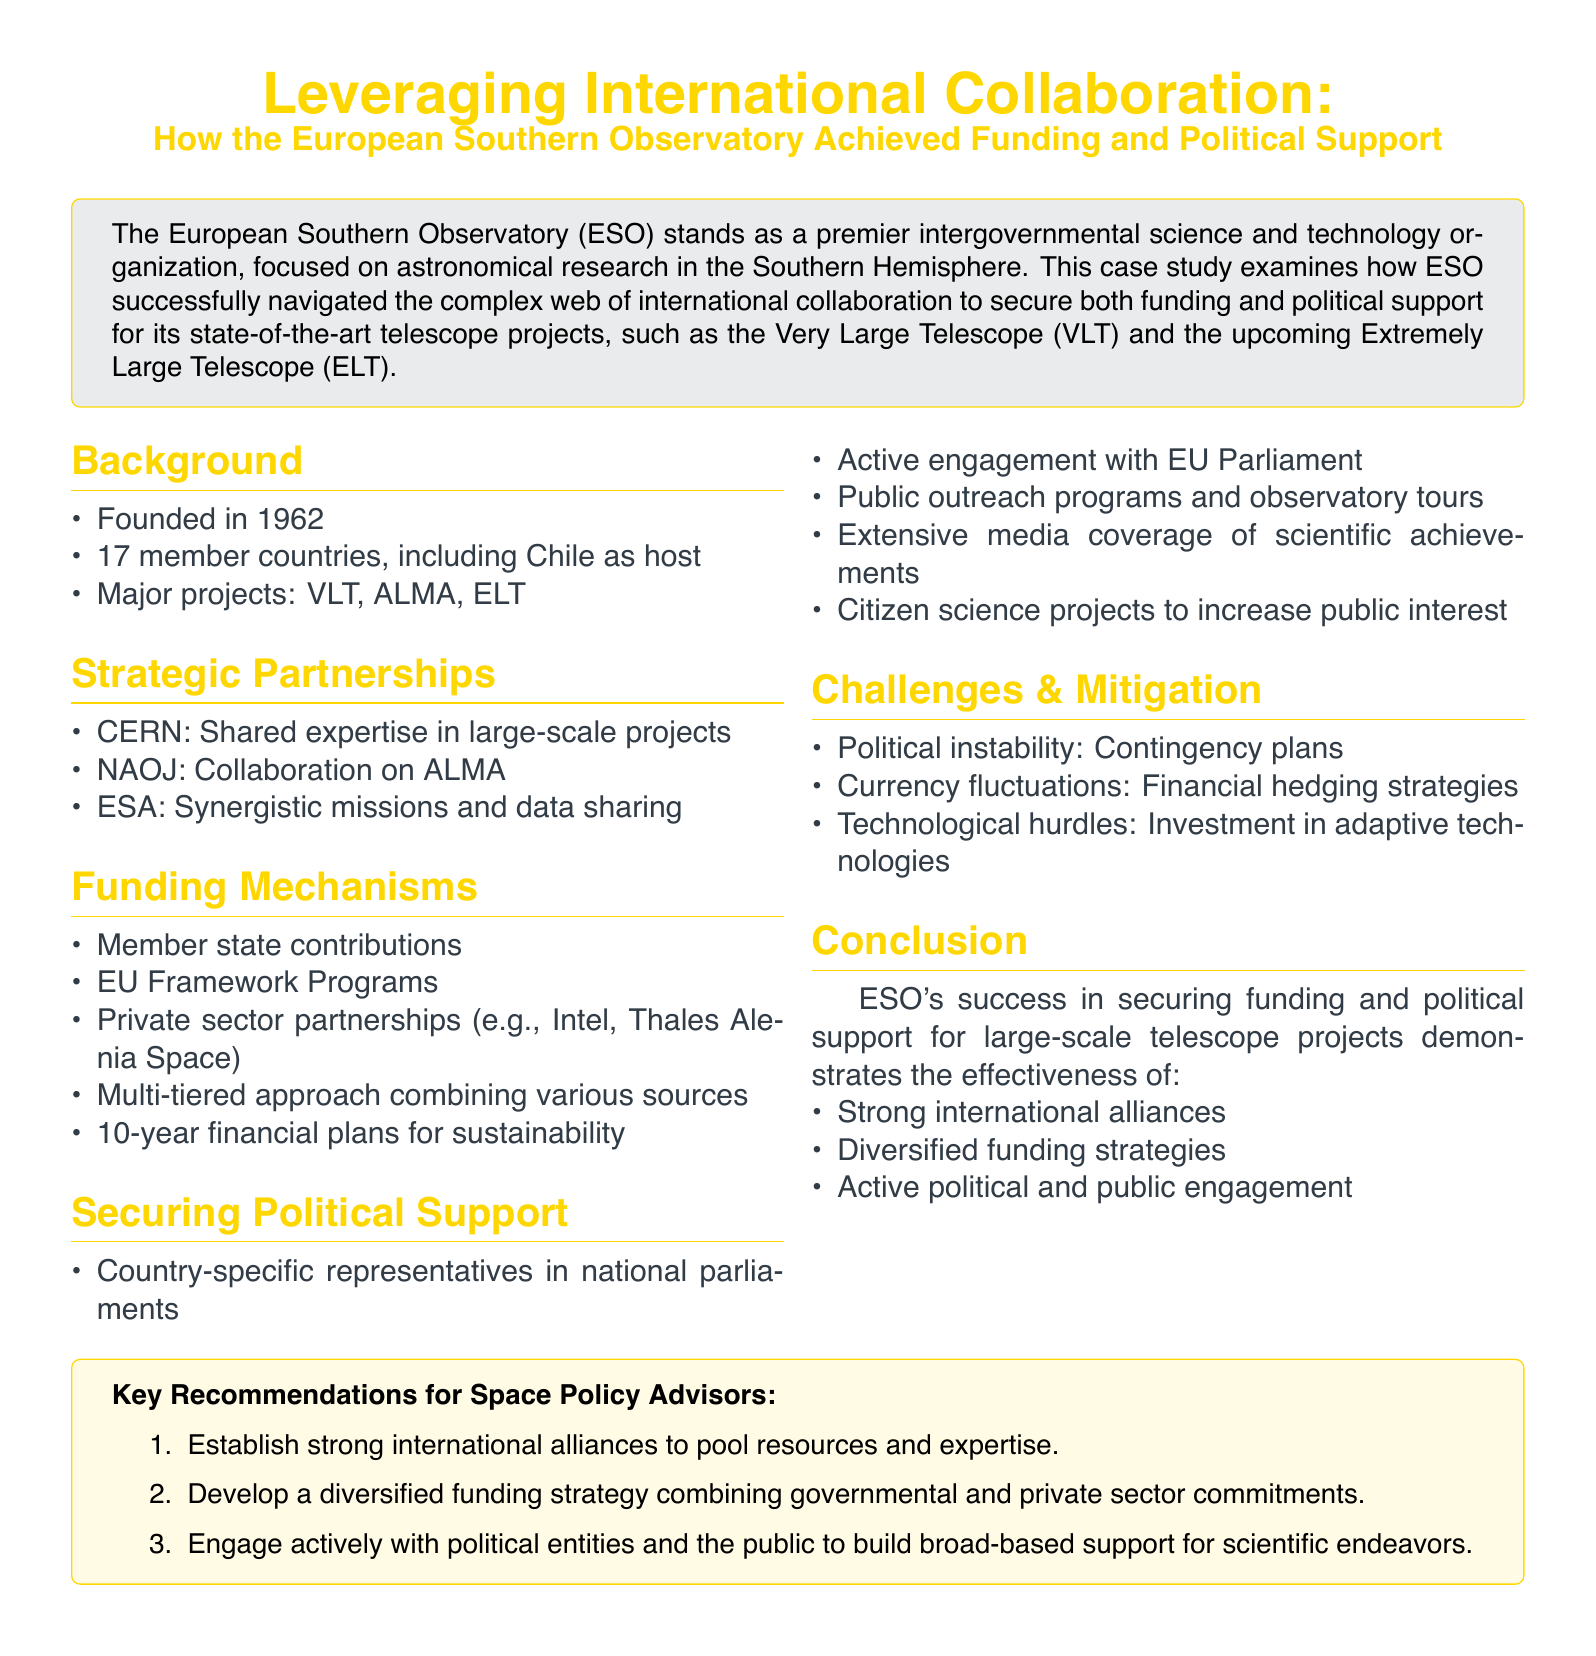What year was ESO founded? The document states that ESO was founded in 1962.
Answer: 1962 How many member countries are there in ESO? The document mentions that ESO has 17 member countries.
Answer: 17 What is one of the major projects of ESO? The document lists major projects including the Very Large Telescope (VLT), ALMA, and the Extremely Large Telescope (ELT).
Answer: Very Large Telescope Which organization does ESO collaborate with on ALMA? The document names NAOJ as the collaborator on ALMA.
Answer: NAOJ What kind of funding strategy does ESO use? The document describes ESO's funding strategy as a multi-tiered approach combining various sources.
Answer: Multi-tiered approach What type of programs did ESO implement to engage the public? The document mentions public outreach programs and citizen science projects to increase public interest.
Answer: Public outreach programs What was a key challenge for ESO that involved financial risk? The document states currency fluctuations as a challenge and mentions financial hedging strategies for mitigation.
Answer: Currency fluctuations What is a recommendation for space policy advisors? The document lists strong international alliances as a key recommendation.
Answer: Strong international alliances How many years do the financial plans cover for sustainability? The document mentions 10-year financial plans for sustainability.
Answer: 10-year 